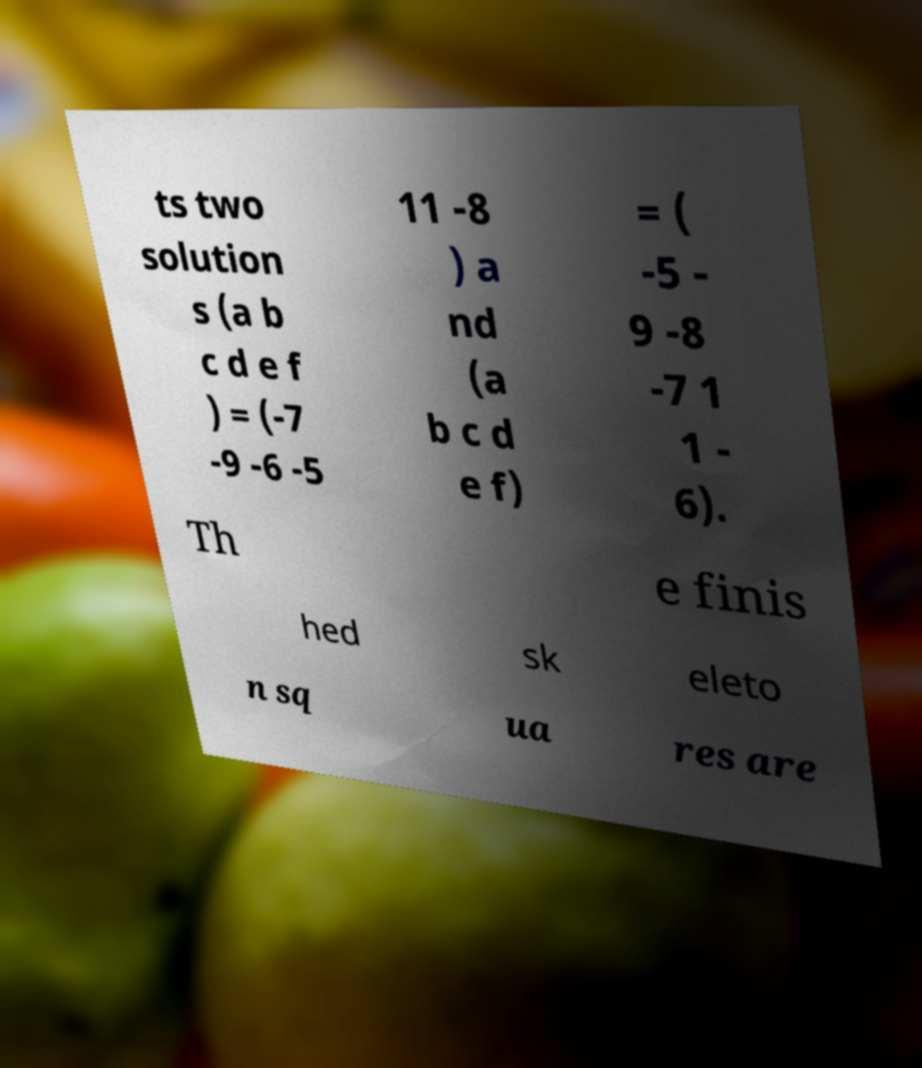Could you extract and type out the text from this image? ts two solution s (a b c d e f ) = (-7 -9 -6 -5 11 -8 ) a nd (a b c d e f) = ( -5 - 9 -8 -7 1 1 - 6). Th e finis hed sk eleto n sq ua res are 